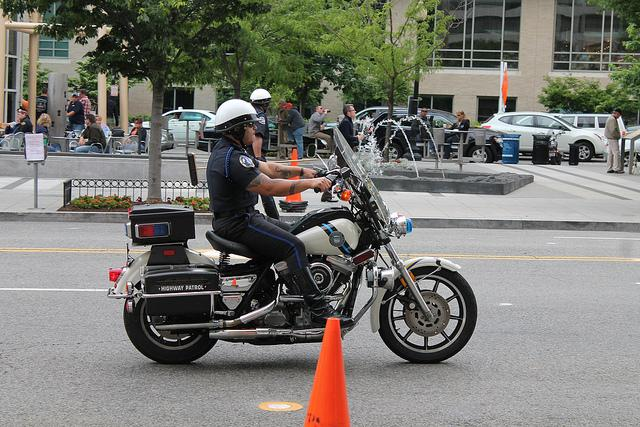Where is the officer riding here?

Choices:
A) parade route
B) brazil
C) fire
D) perp. capture parade route 